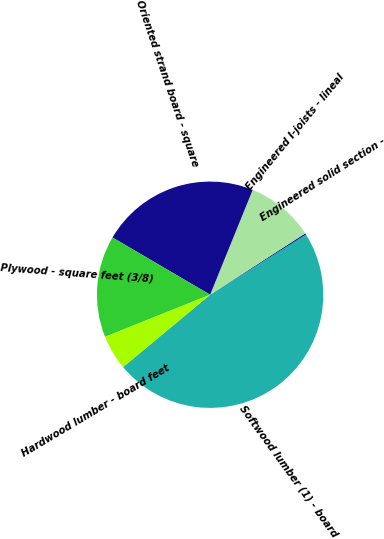Convert chart to OTSL. <chart><loc_0><loc_0><loc_500><loc_500><pie_chart><fcel>Softwood lumber (1) - board<fcel>Engineered solid section -<fcel>Engineered I-joists - lineal<fcel>Oriented strand board - square<fcel>Plywood - square feet (3/8)<fcel>Hardwood lumber - board feet<nl><fcel>47.89%<fcel>0.2%<fcel>9.74%<fcel>22.7%<fcel>14.51%<fcel>4.97%<nl></chart> 